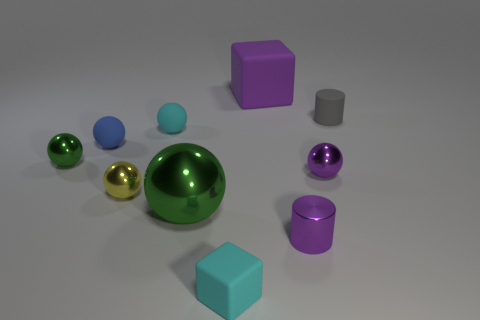Subtract 3 balls. How many balls are left? 3 Subtract all blue rubber spheres. How many spheres are left? 5 Subtract all yellow spheres. How many spheres are left? 5 Subtract all yellow spheres. Subtract all green cubes. How many spheres are left? 5 Subtract all balls. How many objects are left? 4 Subtract all cyan rubber blocks. Subtract all tiny balls. How many objects are left? 4 Add 8 tiny cyan rubber blocks. How many tiny cyan rubber blocks are left? 9 Add 8 small red matte spheres. How many small red matte spheres exist? 8 Subtract 0 brown cylinders. How many objects are left? 10 